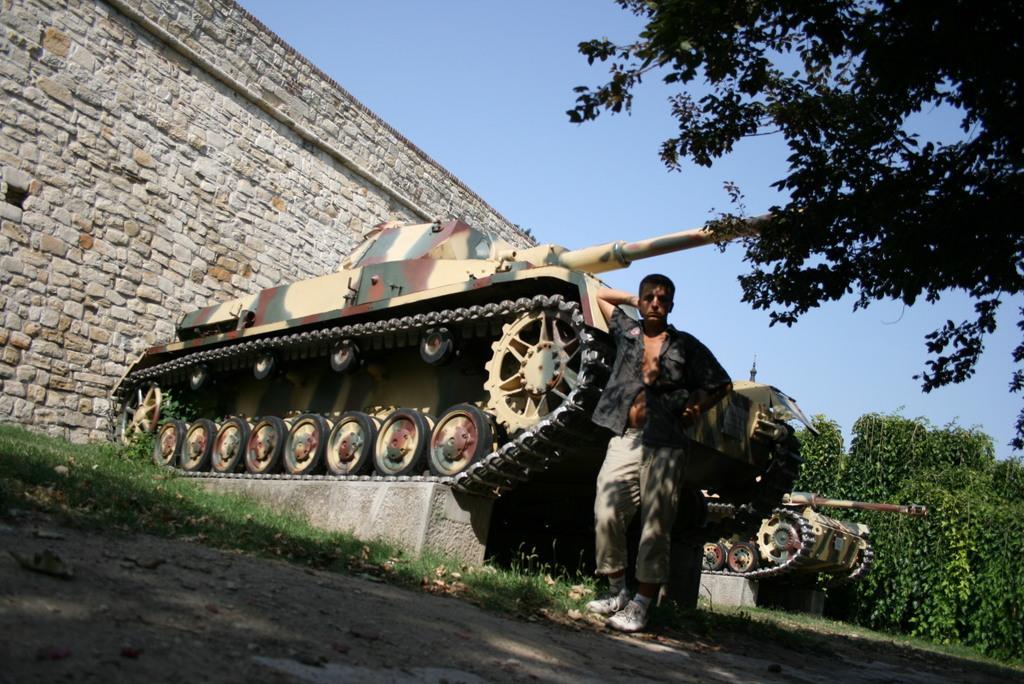Can you describe this image briefly? In this image, we can see a man standing and at the right side there are some green color trees, at the top there is a blue color sky. 